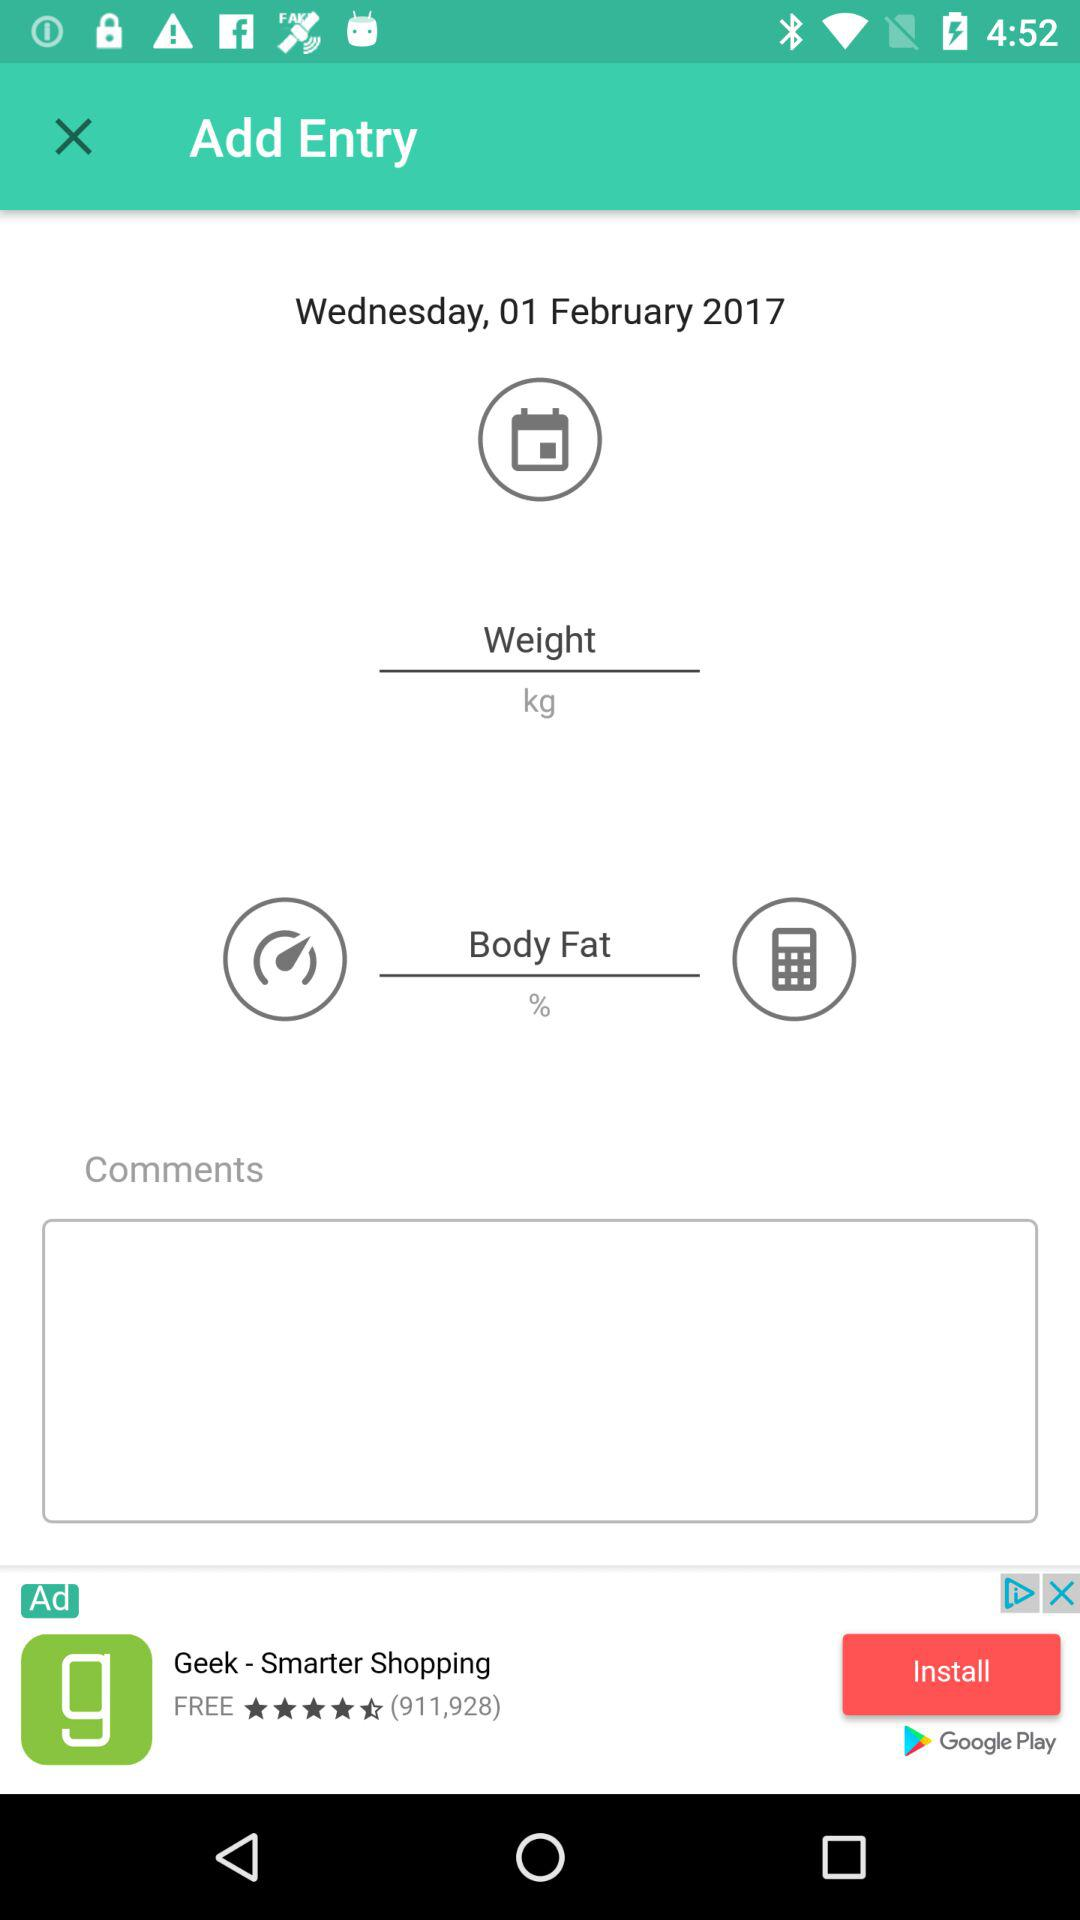What is the shown date? The shown date is Wednesday, February 1, 2017. 